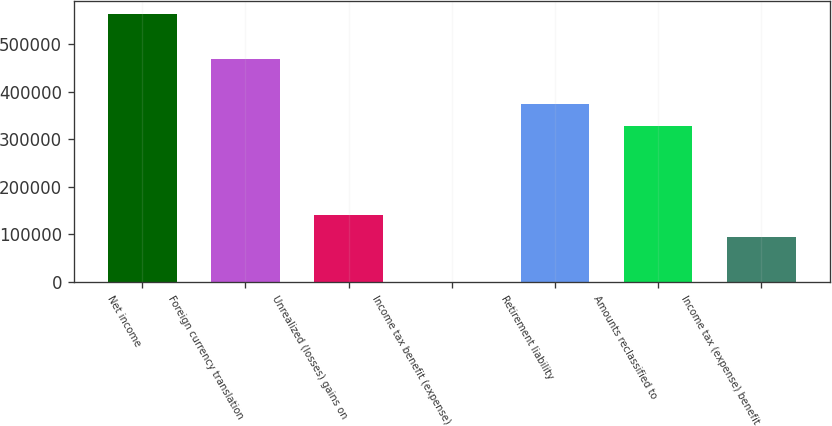Convert chart. <chart><loc_0><loc_0><loc_500><loc_500><bar_chart><fcel>Net income<fcel>Foreign currency translation<fcel>Unrealized (losses) gains on<fcel>Income tax benefit (expense)<fcel>Retirement liability<fcel>Amounts reclassified to<fcel>Income tax (expense) benefit<nl><fcel>562857<fcel>469053<fcel>140738<fcel>31<fcel>375249<fcel>328346<fcel>93835.4<nl></chart> 